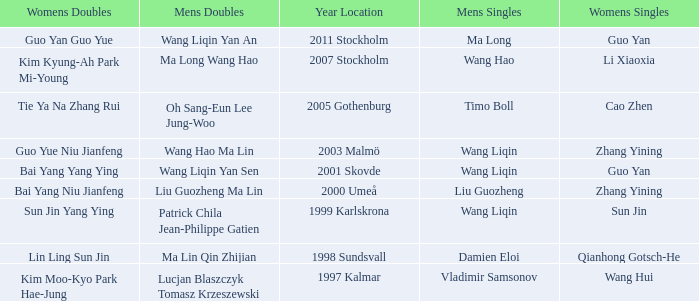How many times has Ma Long won the men's singles? 1.0. 